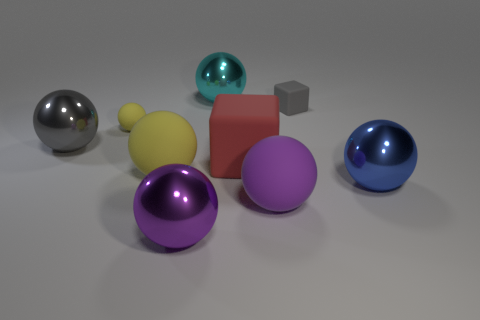Subtract all big purple spheres. How many spheres are left? 5 Subtract 2 cubes. How many cubes are left? 0 Subtract all balls. How many objects are left? 2 Subtract all blue blocks. How many yellow balls are left? 2 Subtract all large purple spheres. Subtract all large cyan things. How many objects are left? 6 Add 7 big red objects. How many big red objects are left? 8 Add 2 red matte blocks. How many red matte blocks exist? 3 Subtract all yellow spheres. How many spheres are left? 5 Subtract 1 purple balls. How many objects are left? 8 Subtract all blue blocks. Subtract all gray spheres. How many blocks are left? 2 